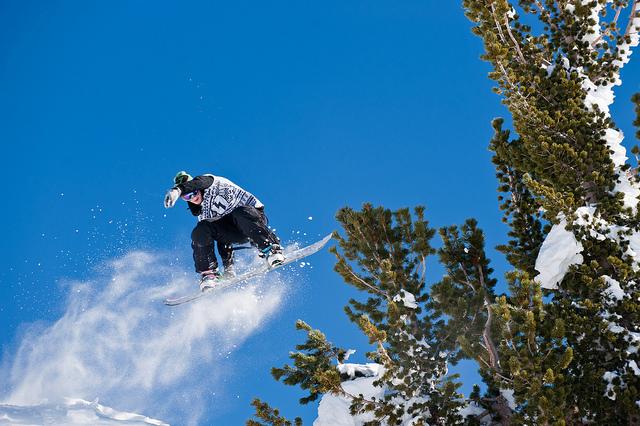How many clouds are in the sky?
Quick response, please. 0. Is the snowboarder on the ground?
Keep it brief. No. Is this day clear and sunny?
Give a very brief answer. Yes. 